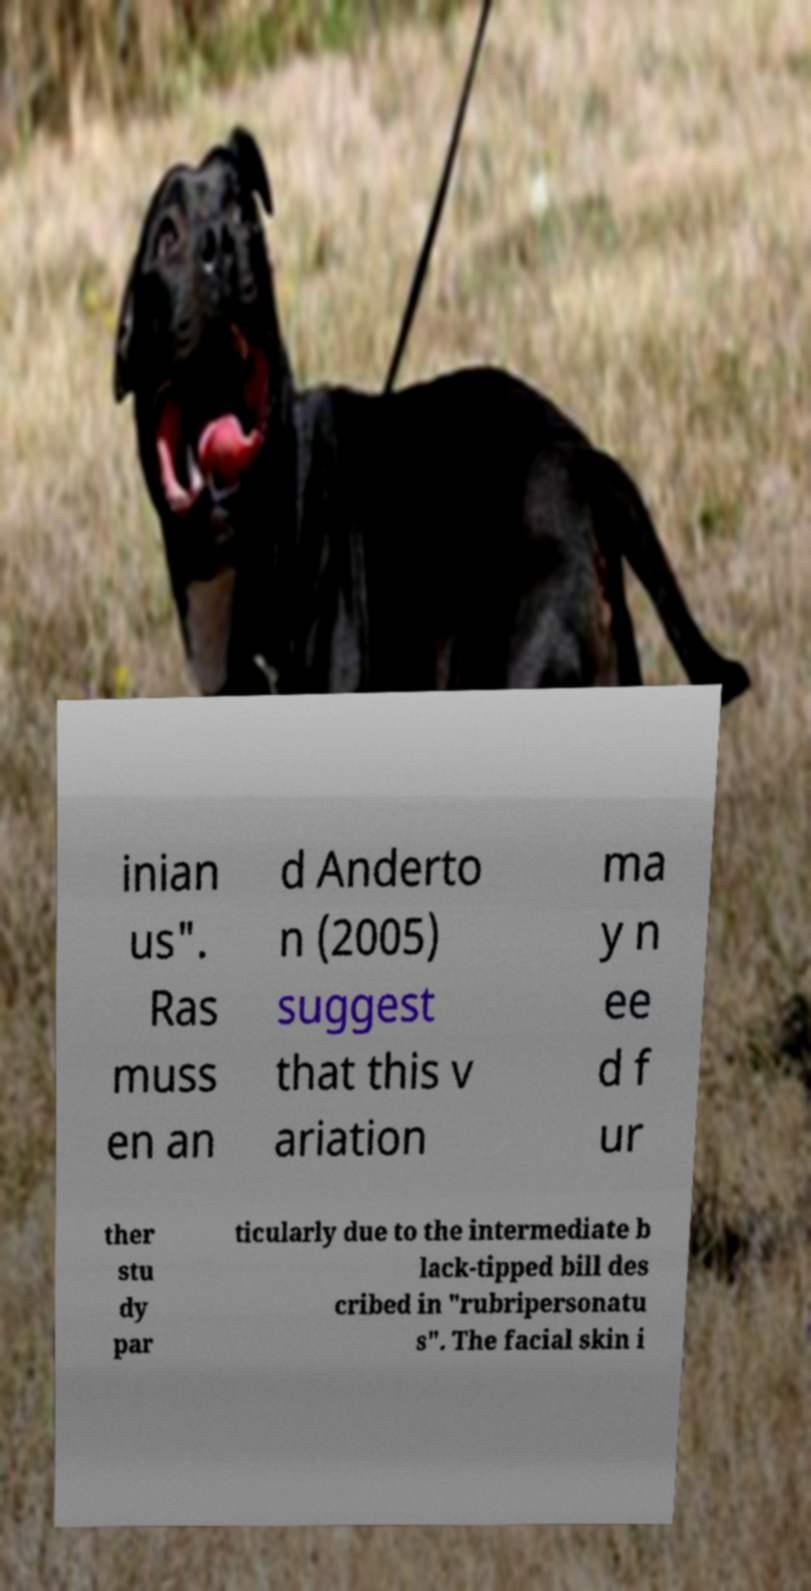Can you read and provide the text displayed in the image?This photo seems to have some interesting text. Can you extract and type it out for me? inian us". Ras muss en an d Anderto n (2005) suggest that this v ariation ma y n ee d f ur ther stu dy par ticularly due to the intermediate b lack-tipped bill des cribed in "rubripersonatu s". The facial skin i 